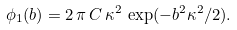<formula> <loc_0><loc_0><loc_500><loc_500>\phi _ { 1 } ( b ) = 2 \, \pi \, C \, \kappa ^ { 2 } \, \exp ( - b ^ { 2 } \kappa ^ { 2 } / 2 ) .</formula> 